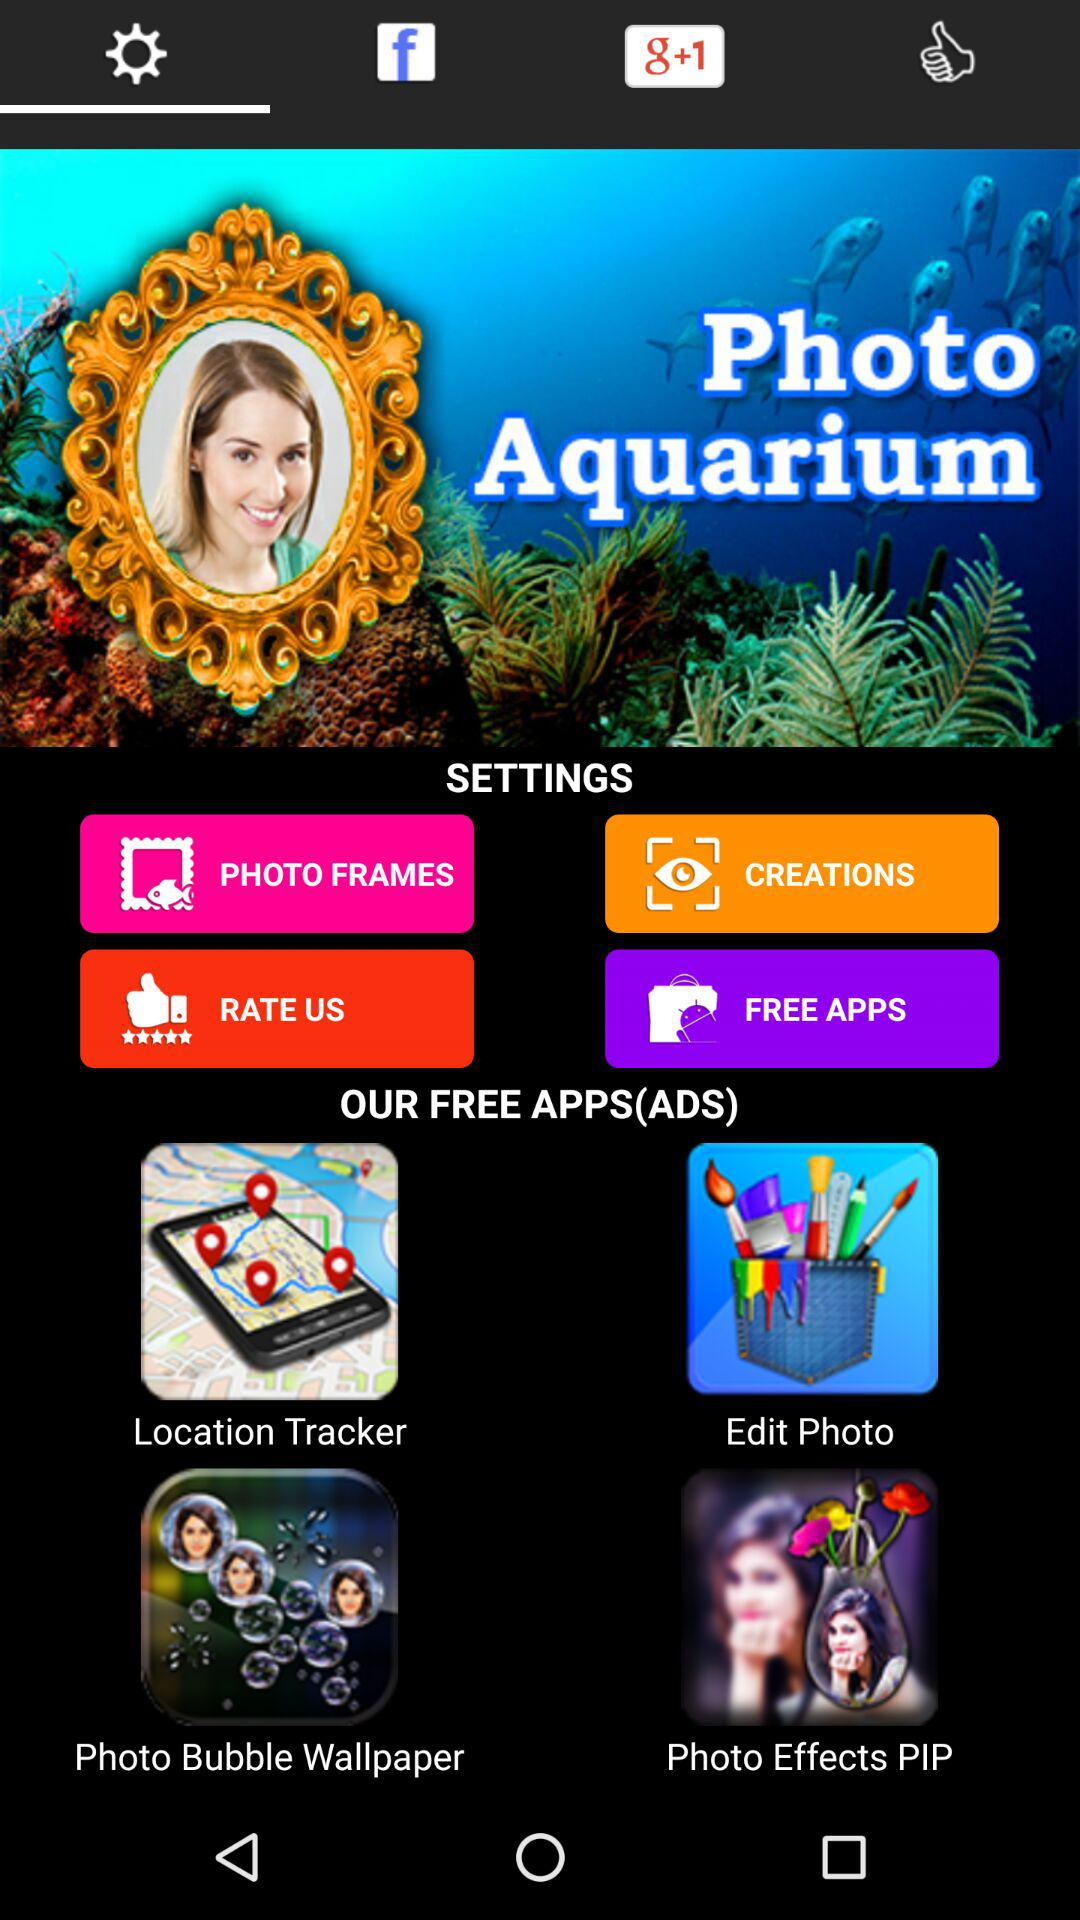Which tab am I on? You are on the "Settings" tab. 